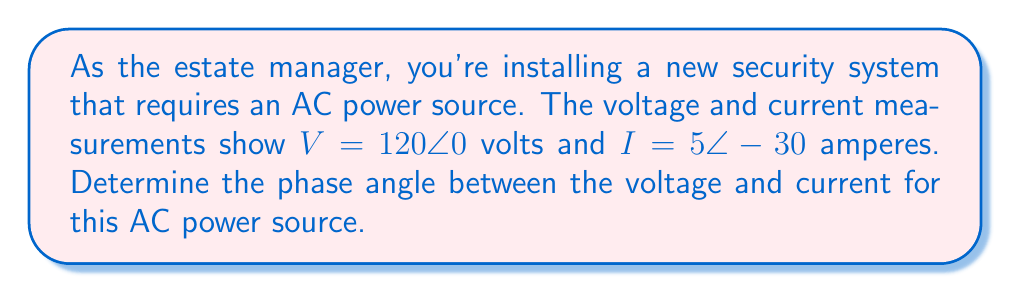What is the answer to this math problem? To find the phase angle between voltage and current in an AC circuit, we need to follow these steps:

1) First, recall that the phase angle is the difference between the voltage angle and the current angle.

2) We're given:
   Voltage: $V = 120\angle 0°$ volts
   Current: $I = 5\angle -30°$ amperes

3) The phase angle $\phi$ is calculated as:
   $$\phi = \theta_V - \theta_I$$
   where $\theta_V$ is the voltage angle and $\theta_I$ is the current angle.

4) Substituting the values:
   $$\phi = 0° - (-30°)$$

5) Simplify:
   $$\phi = 0° + 30° = 30°$$

6) Therefore, the phase angle between voltage and current is 30°.

This positive phase angle indicates that the voltage leads the current, which is typical for an inductive load in the security equipment.
Answer: $30°$ 